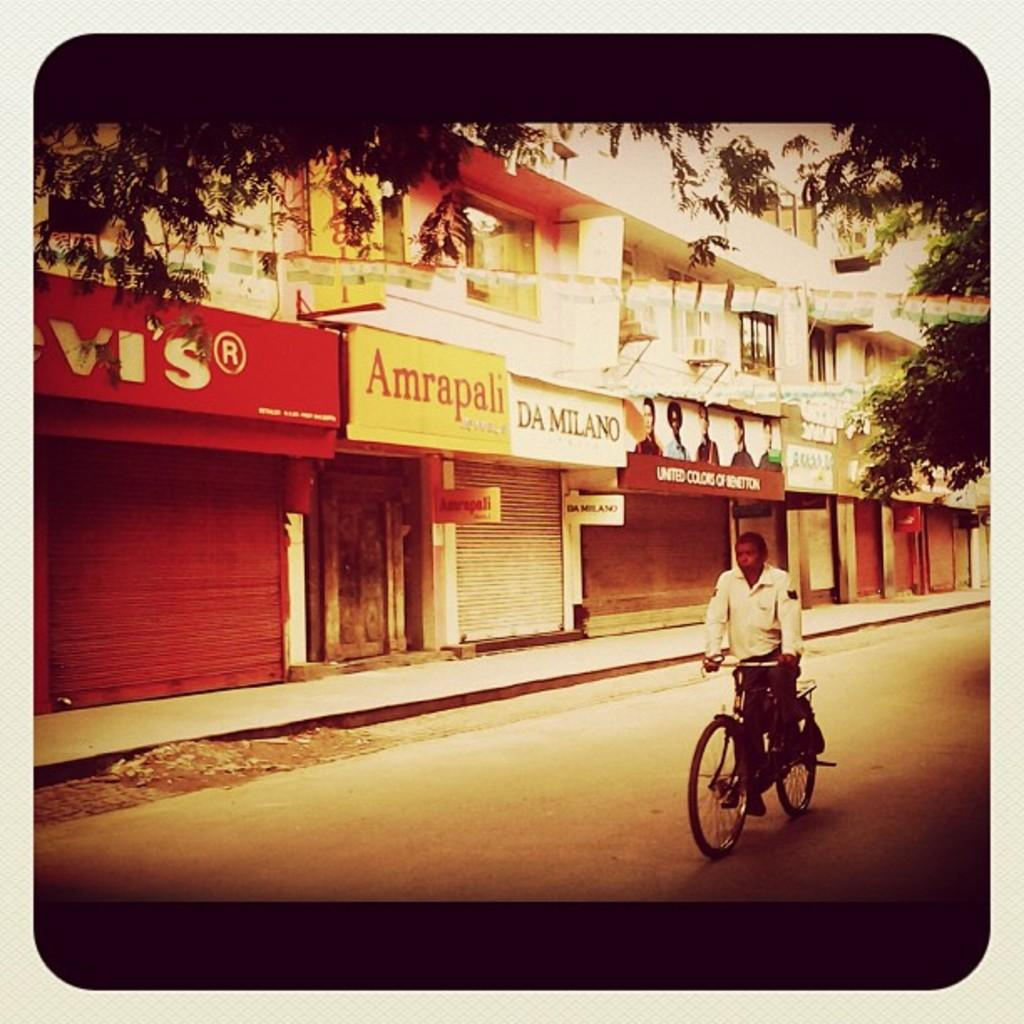What is the main subject of the image? There is a person riding a bicycle in the image. What can be seen in the background of the image? There are buildings and boards in the background of the image. What type of vegetation is visible at the top of the image? Trees are visible at the top of the image. What additional objects are present in the image? Flags are present in the image. Can you tell me how many basketballs are visible in the image? There are no basketballs present in the image. What type of grass is growing near the trees in the image? There is no grass visible in the image; only trees are mentioned at the top of the image. 